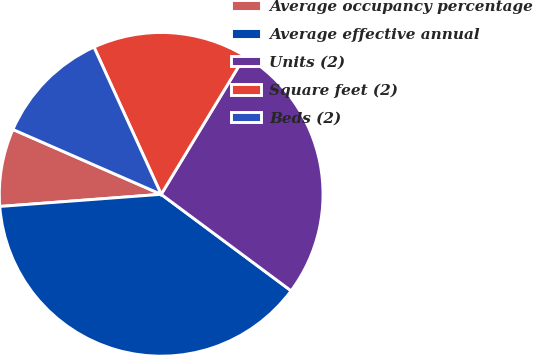<chart> <loc_0><loc_0><loc_500><loc_500><pie_chart><fcel>Average occupancy percentage<fcel>Average effective annual<fcel>Units (2)<fcel>Square feet (2)<fcel>Beds (2)<nl><fcel>7.76%<fcel>38.64%<fcel>26.5%<fcel>15.48%<fcel>11.62%<nl></chart> 